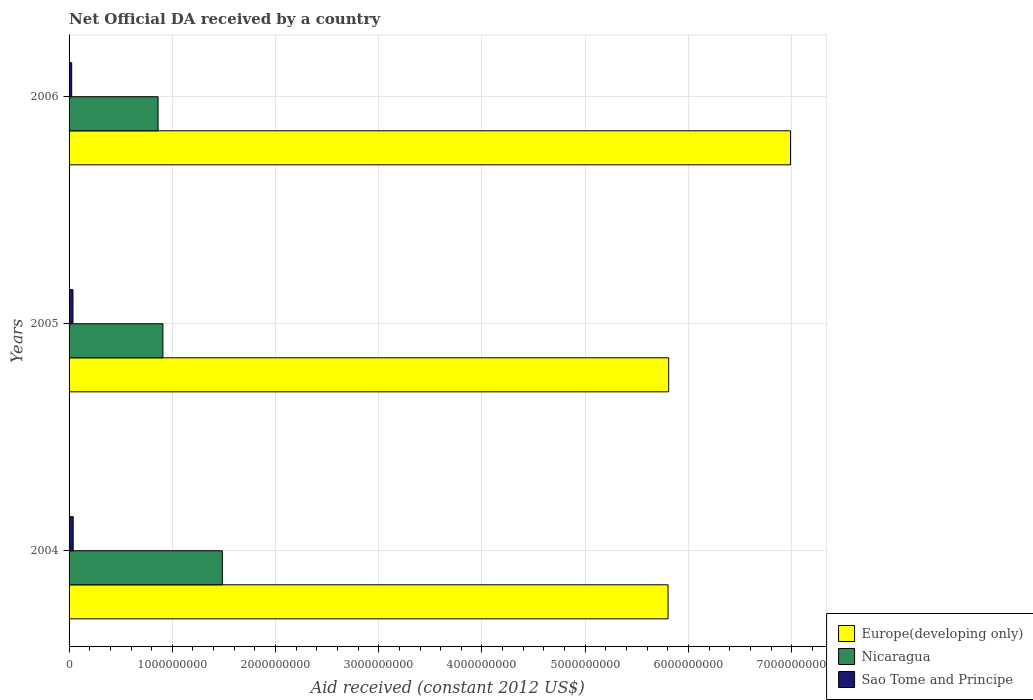How many different coloured bars are there?
Keep it short and to the point. 3. How many groups of bars are there?
Give a very brief answer. 3. Are the number of bars per tick equal to the number of legend labels?
Make the answer very short. Yes. How many bars are there on the 3rd tick from the top?
Keep it short and to the point. 3. What is the label of the 3rd group of bars from the top?
Ensure brevity in your answer.  2004. In how many cases, is the number of bars for a given year not equal to the number of legend labels?
Your answer should be compact. 0. What is the net official development assistance aid received in Europe(developing only) in 2006?
Make the answer very short. 6.99e+09. Across all years, what is the maximum net official development assistance aid received in Nicaragua?
Your answer should be very brief. 1.48e+09. Across all years, what is the minimum net official development assistance aid received in Europe(developing only)?
Give a very brief answer. 5.80e+09. In which year was the net official development assistance aid received in Sao Tome and Principe maximum?
Give a very brief answer. 2004. What is the total net official development assistance aid received in Sao Tome and Principe in the graph?
Make the answer very short. 1.03e+08. What is the difference between the net official development assistance aid received in Sao Tome and Principe in 2005 and that in 2006?
Provide a short and direct response. 1.26e+07. What is the difference between the net official development assistance aid received in Nicaragua in 2004 and the net official development assistance aid received in Europe(developing only) in 2005?
Your answer should be compact. -4.32e+09. What is the average net official development assistance aid received in Sao Tome and Principe per year?
Provide a succinct answer. 3.44e+07. In the year 2005, what is the difference between the net official development assistance aid received in Nicaragua and net official development assistance aid received in Sao Tome and Principe?
Ensure brevity in your answer.  8.71e+08. What is the ratio of the net official development assistance aid received in Nicaragua in 2004 to that in 2006?
Ensure brevity in your answer.  1.72. Is the difference between the net official development assistance aid received in Nicaragua in 2005 and 2006 greater than the difference between the net official development assistance aid received in Sao Tome and Principe in 2005 and 2006?
Ensure brevity in your answer.  Yes. What is the difference between the highest and the second highest net official development assistance aid received in Sao Tome and Principe?
Provide a short and direct response. 2.02e+06. What is the difference between the highest and the lowest net official development assistance aid received in Sao Tome and Principe?
Offer a terse response. 1.46e+07. In how many years, is the net official development assistance aid received in Sao Tome and Principe greater than the average net official development assistance aid received in Sao Tome and Principe taken over all years?
Offer a very short reply. 2. Is the sum of the net official development assistance aid received in Nicaragua in 2005 and 2006 greater than the maximum net official development assistance aid received in Sao Tome and Principe across all years?
Offer a very short reply. Yes. What does the 3rd bar from the top in 2005 represents?
Ensure brevity in your answer.  Europe(developing only). What does the 3rd bar from the bottom in 2005 represents?
Your answer should be compact. Sao Tome and Principe. Is it the case that in every year, the sum of the net official development assistance aid received in Sao Tome and Principe and net official development assistance aid received in Nicaragua is greater than the net official development assistance aid received in Europe(developing only)?
Ensure brevity in your answer.  No. How many bars are there?
Your response must be concise. 9. Are the values on the major ticks of X-axis written in scientific E-notation?
Your answer should be very brief. No. How many legend labels are there?
Your answer should be compact. 3. What is the title of the graph?
Your response must be concise. Net Official DA received by a country. Does "Turkey" appear as one of the legend labels in the graph?
Your answer should be very brief. No. What is the label or title of the X-axis?
Your response must be concise. Aid received (constant 2012 US$). What is the Aid received (constant 2012 US$) in Europe(developing only) in 2004?
Ensure brevity in your answer.  5.80e+09. What is the Aid received (constant 2012 US$) in Nicaragua in 2004?
Make the answer very short. 1.48e+09. What is the Aid received (constant 2012 US$) of Sao Tome and Principe in 2004?
Provide a short and direct response. 3.99e+07. What is the Aid received (constant 2012 US$) of Europe(developing only) in 2005?
Provide a short and direct response. 5.81e+09. What is the Aid received (constant 2012 US$) of Nicaragua in 2005?
Provide a short and direct response. 9.09e+08. What is the Aid received (constant 2012 US$) of Sao Tome and Principe in 2005?
Provide a short and direct response. 3.79e+07. What is the Aid received (constant 2012 US$) of Europe(developing only) in 2006?
Your response must be concise. 6.99e+09. What is the Aid received (constant 2012 US$) of Nicaragua in 2006?
Offer a very short reply. 8.62e+08. What is the Aid received (constant 2012 US$) of Sao Tome and Principe in 2006?
Make the answer very short. 2.53e+07. Across all years, what is the maximum Aid received (constant 2012 US$) of Europe(developing only)?
Your response must be concise. 6.99e+09. Across all years, what is the maximum Aid received (constant 2012 US$) of Nicaragua?
Provide a succinct answer. 1.48e+09. Across all years, what is the maximum Aid received (constant 2012 US$) of Sao Tome and Principe?
Keep it short and to the point. 3.99e+07. Across all years, what is the minimum Aid received (constant 2012 US$) in Europe(developing only)?
Make the answer very short. 5.80e+09. Across all years, what is the minimum Aid received (constant 2012 US$) of Nicaragua?
Keep it short and to the point. 8.62e+08. Across all years, what is the minimum Aid received (constant 2012 US$) in Sao Tome and Principe?
Give a very brief answer. 2.53e+07. What is the total Aid received (constant 2012 US$) in Europe(developing only) in the graph?
Keep it short and to the point. 1.86e+1. What is the total Aid received (constant 2012 US$) in Nicaragua in the graph?
Ensure brevity in your answer.  3.26e+09. What is the total Aid received (constant 2012 US$) in Sao Tome and Principe in the graph?
Ensure brevity in your answer.  1.03e+08. What is the difference between the Aid received (constant 2012 US$) in Europe(developing only) in 2004 and that in 2005?
Your response must be concise. -6.10e+06. What is the difference between the Aid received (constant 2012 US$) of Nicaragua in 2004 and that in 2005?
Provide a succinct answer. 5.76e+08. What is the difference between the Aid received (constant 2012 US$) in Sao Tome and Principe in 2004 and that in 2005?
Your answer should be compact. 2.02e+06. What is the difference between the Aid received (constant 2012 US$) of Europe(developing only) in 2004 and that in 2006?
Offer a terse response. -1.19e+09. What is the difference between the Aid received (constant 2012 US$) of Nicaragua in 2004 and that in 2006?
Keep it short and to the point. 6.22e+08. What is the difference between the Aid received (constant 2012 US$) of Sao Tome and Principe in 2004 and that in 2006?
Make the answer very short. 1.46e+07. What is the difference between the Aid received (constant 2012 US$) in Europe(developing only) in 2005 and that in 2006?
Keep it short and to the point. -1.18e+09. What is the difference between the Aid received (constant 2012 US$) in Nicaragua in 2005 and that in 2006?
Your response must be concise. 4.68e+07. What is the difference between the Aid received (constant 2012 US$) of Sao Tome and Principe in 2005 and that in 2006?
Your answer should be compact. 1.26e+07. What is the difference between the Aid received (constant 2012 US$) of Europe(developing only) in 2004 and the Aid received (constant 2012 US$) of Nicaragua in 2005?
Keep it short and to the point. 4.89e+09. What is the difference between the Aid received (constant 2012 US$) of Europe(developing only) in 2004 and the Aid received (constant 2012 US$) of Sao Tome and Principe in 2005?
Your answer should be very brief. 5.76e+09. What is the difference between the Aid received (constant 2012 US$) in Nicaragua in 2004 and the Aid received (constant 2012 US$) in Sao Tome and Principe in 2005?
Make the answer very short. 1.45e+09. What is the difference between the Aid received (constant 2012 US$) of Europe(developing only) in 2004 and the Aid received (constant 2012 US$) of Nicaragua in 2006?
Your response must be concise. 4.94e+09. What is the difference between the Aid received (constant 2012 US$) in Europe(developing only) in 2004 and the Aid received (constant 2012 US$) in Sao Tome and Principe in 2006?
Ensure brevity in your answer.  5.78e+09. What is the difference between the Aid received (constant 2012 US$) of Nicaragua in 2004 and the Aid received (constant 2012 US$) of Sao Tome and Principe in 2006?
Offer a very short reply. 1.46e+09. What is the difference between the Aid received (constant 2012 US$) of Europe(developing only) in 2005 and the Aid received (constant 2012 US$) of Nicaragua in 2006?
Keep it short and to the point. 4.95e+09. What is the difference between the Aid received (constant 2012 US$) of Europe(developing only) in 2005 and the Aid received (constant 2012 US$) of Sao Tome and Principe in 2006?
Make the answer very short. 5.78e+09. What is the difference between the Aid received (constant 2012 US$) in Nicaragua in 2005 and the Aid received (constant 2012 US$) in Sao Tome and Principe in 2006?
Ensure brevity in your answer.  8.84e+08. What is the average Aid received (constant 2012 US$) of Europe(developing only) per year?
Make the answer very short. 6.20e+09. What is the average Aid received (constant 2012 US$) in Nicaragua per year?
Ensure brevity in your answer.  1.09e+09. What is the average Aid received (constant 2012 US$) of Sao Tome and Principe per year?
Keep it short and to the point. 3.44e+07. In the year 2004, what is the difference between the Aid received (constant 2012 US$) in Europe(developing only) and Aid received (constant 2012 US$) in Nicaragua?
Make the answer very short. 4.32e+09. In the year 2004, what is the difference between the Aid received (constant 2012 US$) of Europe(developing only) and Aid received (constant 2012 US$) of Sao Tome and Principe?
Make the answer very short. 5.76e+09. In the year 2004, what is the difference between the Aid received (constant 2012 US$) in Nicaragua and Aid received (constant 2012 US$) in Sao Tome and Principe?
Offer a very short reply. 1.44e+09. In the year 2005, what is the difference between the Aid received (constant 2012 US$) of Europe(developing only) and Aid received (constant 2012 US$) of Nicaragua?
Provide a short and direct response. 4.90e+09. In the year 2005, what is the difference between the Aid received (constant 2012 US$) in Europe(developing only) and Aid received (constant 2012 US$) in Sao Tome and Principe?
Your response must be concise. 5.77e+09. In the year 2005, what is the difference between the Aid received (constant 2012 US$) of Nicaragua and Aid received (constant 2012 US$) of Sao Tome and Principe?
Your answer should be very brief. 8.71e+08. In the year 2006, what is the difference between the Aid received (constant 2012 US$) of Europe(developing only) and Aid received (constant 2012 US$) of Nicaragua?
Offer a terse response. 6.13e+09. In the year 2006, what is the difference between the Aid received (constant 2012 US$) in Europe(developing only) and Aid received (constant 2012 US$) in Sao Tome and Principe?
Offer a terse response. 6.96e+09. In the year 2006, what is the difference between the Aid received (constant 2012 US$) of Nicaragua and Aid received (constant 2012 US$) of Sao Tome and Principe?
Your answer should be very brief. 8.37e+08. What is the ratio of the Aid received (constant 2012 US$) of Nicaragua in 2004 to that in 2005?
Provide a succinct answer. 1.63. What is the ratio of the Aid received (constant 2012 US$) of Sao Tome and Principe in 2004 to that in 2005?
Offer a terse response. 1.05. What is the ratio of the Aid received (constant 2012 US$) in Europe(developing only) in 2004 to that in 2006?
Your answer should be compact. 0.83. What is the ratio of the Aid received (constant 2012 US$) of Nicaragua in 2004 to that in 2006?
Offer a terse response. 1.72. What is the ratio of the Aid received (constant 2012 US$) in Sao Tome and Principe in 2004 to that in 2006?
Your answer should be very brief. 1.58. What is the ratio of the Aid received (constant 2012 US$) of Europe(developing only) in 2005 to that in 2006?
Give a very brief answer. 0.83. What is the ratio of the Aid received (constant 2012 US$) of Nicaragua in 2005 to that in 2006?
Your response must be concise. 1.05. What is the ratio of the Aid received (constant 2012 US$) of Sao Tome and Principe in 2005 to that in 2006?
Your answer should be very brief. 1.5. What is the difference between the highest and the second highest Aid received (constant 2012 US$) in Europe(developing only)?
Offer a very short reply. 1.18e+09. What is the difference between the highest and the second highest Aid received (constant 2012 US$) in Nicaragua?
Your response must be concise. 5.76e+08. What is the difference between the highest and the second highest Aid received (constant 2012 US$) in Sao Tome and Principe?
Offer a terse response. 2.02e+06. What is the difference between the highest and the lowest Aid received (constant 2012 US$) of Europe(developing only)?
Your answer should be very brief. 1.19e+09. What is the difference between the highest and the lowest Aid received (constant 2012 US$) of Nicaragua?
Your answer should be very brief. 6.22e+08. What is the difference between the highest and the lowest Aid received (constant 2012 US$) in Sao Tome and Principe?
Keep it short and to the point. 1.46e+07. 